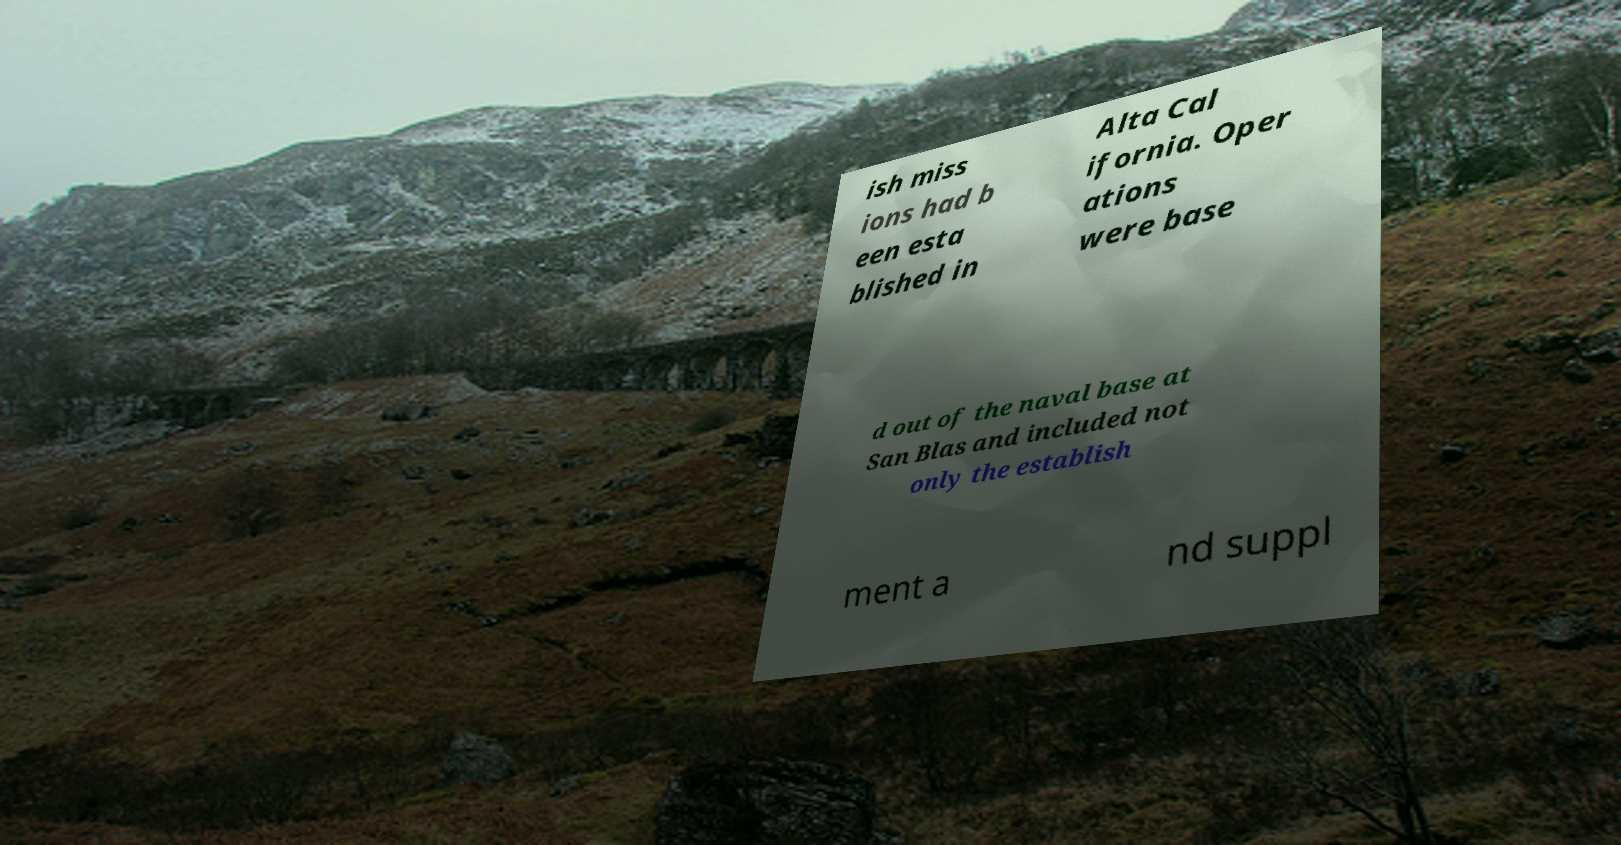Could you extract and type out the text from this image? ish miss ions had b een esta blished in Alta Cal ifornia. Oper ations were base d out of the naval base at San Blas and included not only the establish ment a nd suppl 